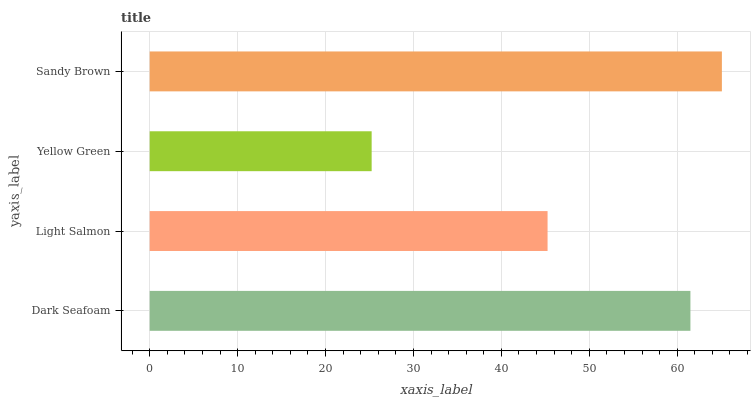Is Yellow Green the minimum?
Answer yes or no. Yes. Is Sandy Brown the maximum?
Answer yes or no. Yes. Is Light Salmon the minimum?
Answer yes or no. No. Is Light Salmon the maximum?
Answer yes or no. No. Is Dark Seafoam greater than Light Salmon?
Answer yes or no. Yes. Is Light Salmon less than Dark Seafoam?
Answer yes or no. Yes. Is Light Salmon greater than Dark Seafoam?
Answer yes or no. No. Is Dark Seafoam less than Light Salmon?
Answer yes or no. No. Is Dark Seafoam the high median?
Answer yes or no. Yes. Is Light Salmon the low median?
Answer yes or no. Yes. Is Light Salmon the high median?
Answer yes or no. No. Is Sandy Brown the low median?
Answer yes or no. No. 